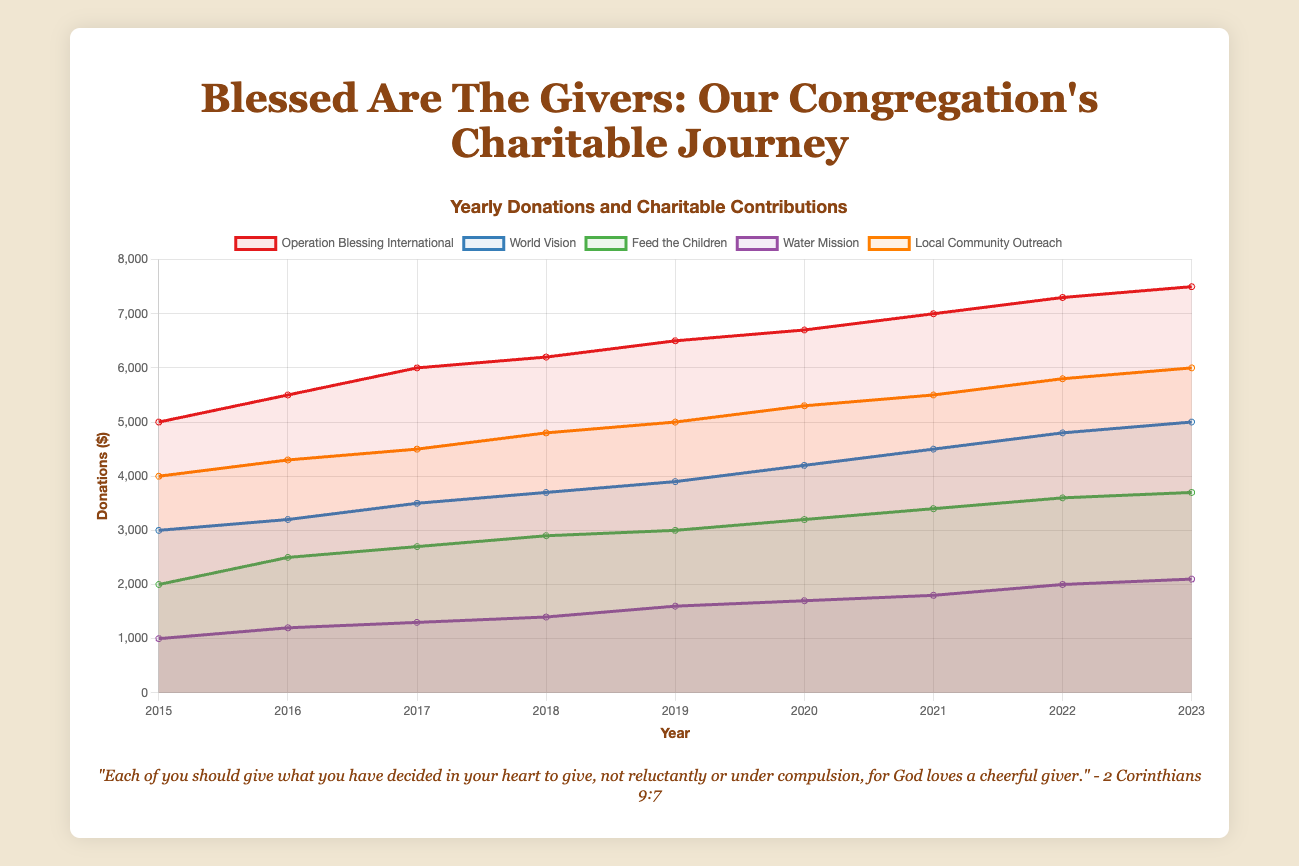Which organization received the highest donation in 2023? Look at the highest data point for the year 2023 in the chart. Check the corresponding organization label for the highest value's trendline.
Answer: Operation Blessing International What was the total donation amount in 2021? Sum the donation values from all organizations for the year 2021. Add up 7000 + 4500 + 3400 + 1800 + 5500.
Answer: 22200 How did the donation to World Vision in 2019 compare to Local Community Outreach in the same year? Locate the data points for World Vision and Local Community Outreach for the year 2019. Compare their heights; World Vision received 3900, and Local Community Outreach received 5000.
Answer: Local Community Outreach received more Which organization had the least increase in donations from 2015 to 2023? Calculate the difference in donation amounts for each organization between 2015 and 2023. The smallest difference indicates the least increase.
Answer: Water Mission What is the average yearly donation to Feed the Children? Sum the yearly donations to Feed the Children from 2015 to 2023, then divide by the number of years (9). The total sum is 2000 + 2500 + 2700 + 2900 + 3000 + 3200 + 3400 + 3600 + 3700. Calculate 27000/9.
Answer: 3000 What is the trend in donation amounts for Operation Blessing International from 2015 to 2023? Observe the trendline for Operation Blessing International from 2015 to 2023. The trend shows a consistent increase each year.
Answer: Increasing trend Which year had the highest combined donations across all organizations? Calculate the total donations for each year by summing the individual donations. Compare the totals to find the highest. For simplicity, calculate the totals and find that 2023 has the highest combined donations.
Answer: 2023 How do donations to Water Mission in 2020 compare to 2018? Locate the data points for Water Mission for the years 2020 and 2018. Compare the two amounts, which are 1700 in 2020 and 1400 in 2018.
Answer: 2020 had higher donations What was the percentage growth in donations to Local Community Outreach from 2016 to 2019? Calculate the percentage growth. The formula is ((Donation in 2019 - Donation in 2016) / Donation in 2016) * 100. Substituting the values: ((5000 - 4300) / 4300) * 100.
Answer: 16.28% Which two organizations showed the most similar trend in their donation growth from 2015 to 2023? Compare the trend lines for each organization visually. Check for parallel lines or similar slopes. World Vision and Local Community Outreach have similar upward trends.
Answer: World Vision and Local Community Outreach 